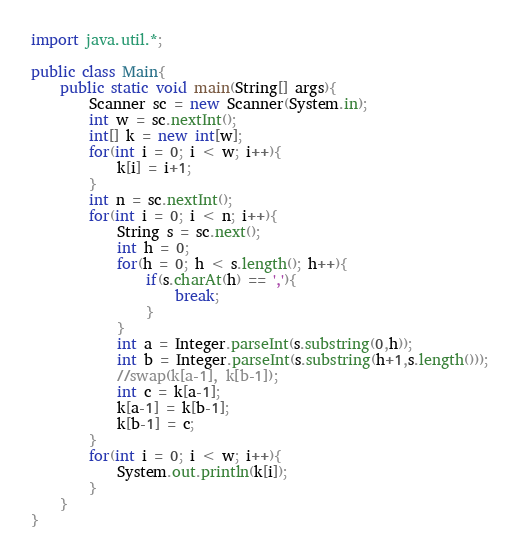<code> <loc_0><loc_0><loc_500><loc_500><_Java_>import java.util.*;

public class Main{
	public static void main(String[] args){
		Scanner sc = new Scanner(System.in);
		int w = sc.nextInt();
		int[] k = new int[w];
		for(int i = 0; i < w; i++){
			k[i] = i+1;
		}
		int n = sc.nextInt();
		for(int i = 0; i < n; i++){
			String s = sc.next();
			int h = 0;
			for(h = 0; h < s.length(); h++){
				if(s.charAt(h) == ','){
					break;
				}
			}
			int a = Integer.parseInt(s.substring(0,h));
			int b = Integer.parseInt(s.substring(h+1,s.length()));
			//swap(k[a-1], k[b-1]);
			int c = k[a-1];
			k[a-1] = k[b-1];
			k[b-1] = c;
		}
		for(int i = 0; i < w; i++){
			System.out.println(k[i]);
		}
	}
}</code> 